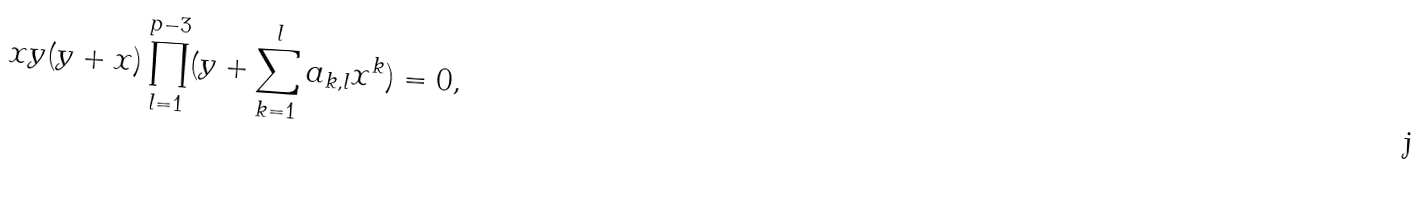<formula> <loc_0><loc_0><loc_500><loc_500>x y ( y + x ) \prod _ { l = 1 } ^ { p - 3 } ( y + \sum _ { k = 1 } ^ { l } a _ { k , l } x ^ { k } ) = 0 ,</formula> 